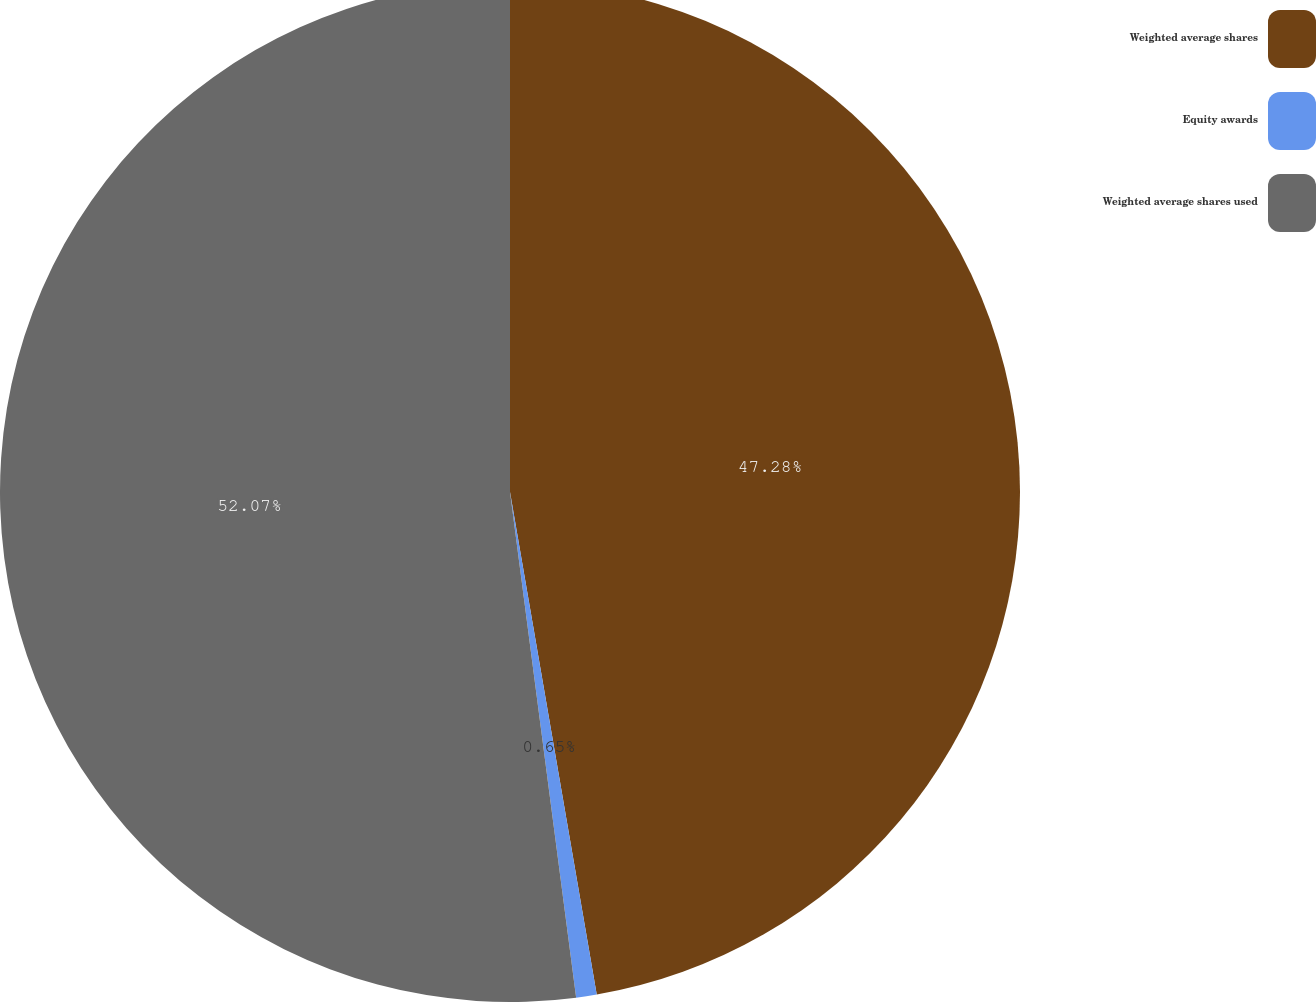Convert chart. <chart><loc_0><loc_0><loc_500><loc_500><pie_chart><fcel>Weighted average shares<fcel>Equity awards<fcel>Weighted average shares used<nl><fcel>47.28%<fcel>0.65%<fcel>52.07%<nl></chart> 